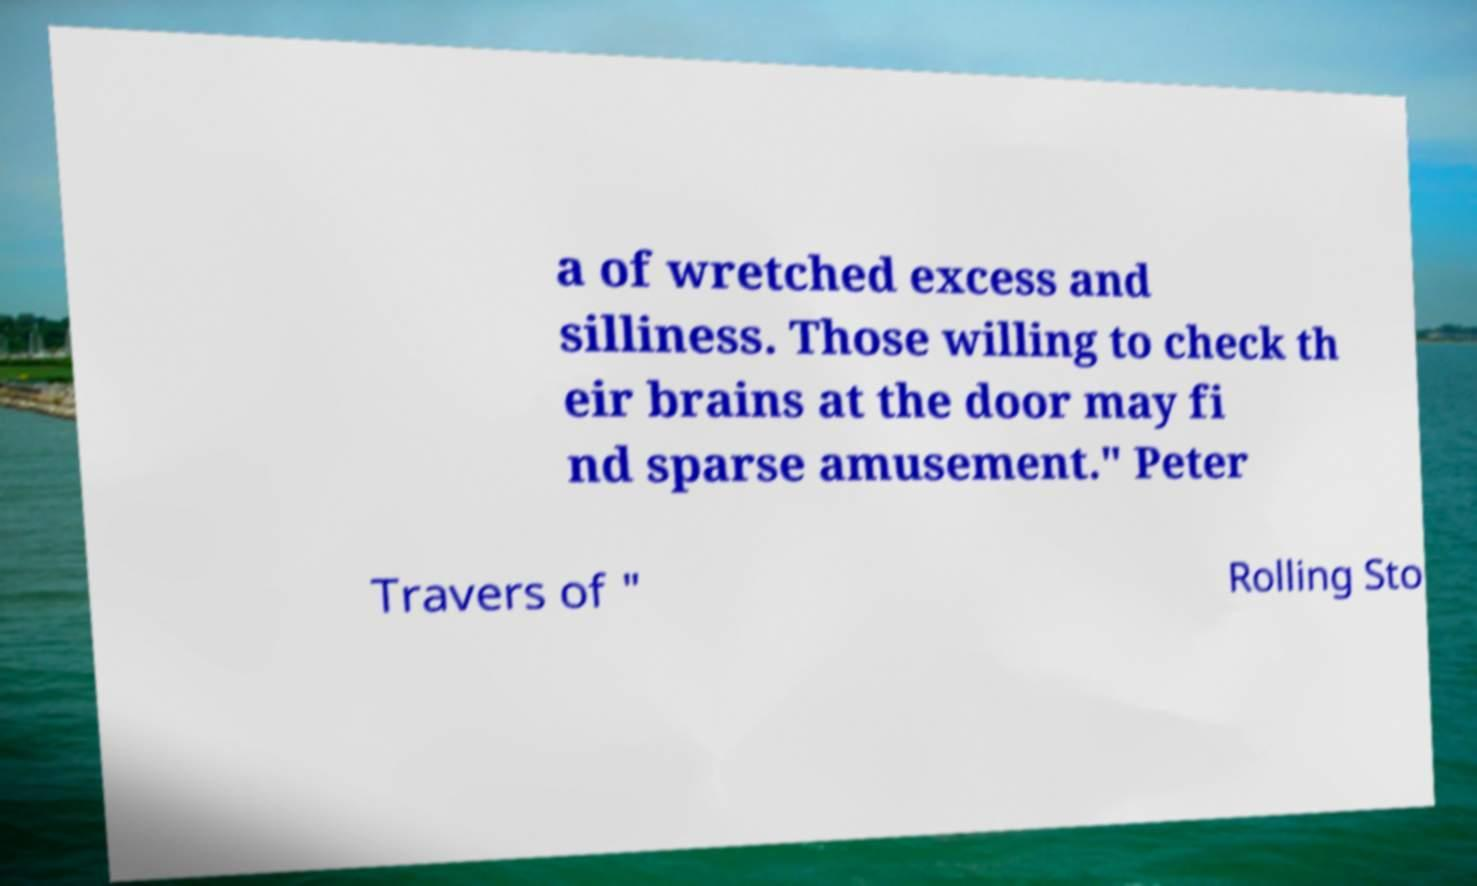Could you assist in decoding the text presented in this image and type it out clearly? a of wretched excess and silliness. Those willing to check th eir brains at the door may fi nd sparse amusement." Peter Travers of " Rolling Sto 